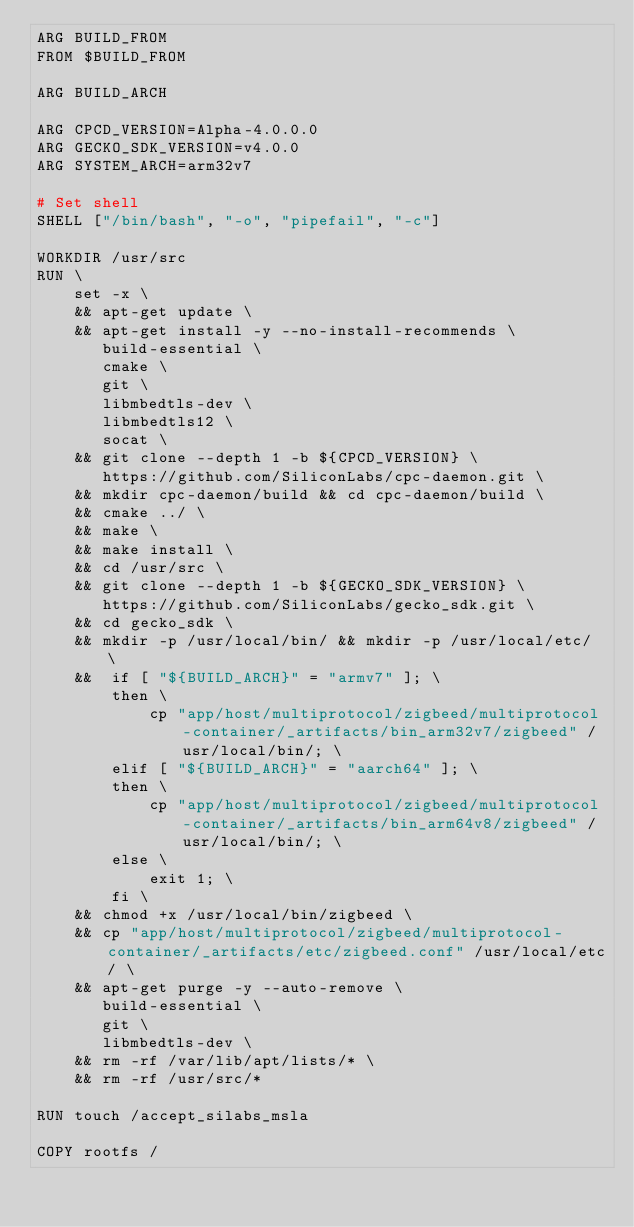Convert code to text. <code><loc_0><loc_0><loc_500><loc_500><_Dockerfile_>ARG BUILD_FROM
FROM $BUILD_FROM

ARG BUILD_ARCH

ARG CPCD_VERSION=Alpha-4.0.0.0
ARG GECKO_SDK_VERSION=v4.0.0
ARG SYSTEM_ARCH=arm32v7

# Set shell
SHELL ["/bin/bash", "-o", "pipefail", "-c"]

WORKDIR /usr/src
RUN \
    set -x \
    && apt-get update \
    && apt-get install -y --no-install-recommends \
       build-essential \
       cmake \
       git \
       libmbedtls-dev \
       libmbedtls12 \
       socat \
    && git clone --depth 1 -b ${CPCD_VERSION} \
       https://github.com/SiliconLabs/cpc-daemon.git \
    && mkdir cpc-daemon/build && cd cpc-daemon/build \
    && cmake ../ \
    && make \
    && make install \
    && cd /usr/src \
    && git clone --depth 1 -b ${GECKO_SDK_VERSION} \
       https://github.com/SiliconLabs/gecko_sdk.git \
    && cd gecko_sdk \
    && mkdir -p /usr/local/bin/ && mkdir -p /usr/local/etc/ \
    &&  if [ "${BUILD_ARCH}" = "armv7" ]; \
        then \
            cp "app/host/multiprotocol/zigbeed/multiprotocol-container/_artifacts/bin_arm32v7/zigbeed" /usr/local/bin/; \
        elif [ "${BUILD_ARCH}" = "aarch64" ]; \
        then \
            cp "app/host/multiprotocol/zigbeed/multiprotocol-container/_artifacts/bin_arm64v8/zigbeed" /usr/local/bin/; \
        else \
            exit 1; \
        fi \
    && chmod +x /usr/local/bin/zigbeed \
    && cp "app/host/multiprotocol/zigbeed/multiprotocol-container/_artifacts/etc/zigbeed.conf" /usr/local/etc/ \
    && apt-get purge -y --auto-remove \
       build-essential \
       git \
       libmbedtls-dev \
    && rm -rf /var/lib/apt/lists/* \
    && rm -rf /usr/src/*

RUN touch /accept_silabs_msla

COPY rootfs /
</code> 